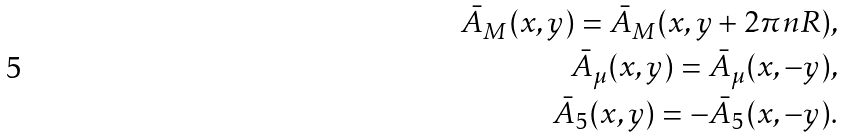Convert formula to latex. <formula><loc_0><loc_0><loc_500><loc_500>\bar { A } _ { M } ( x , y ) = \bar { A } _ { M } ( x , y + 2 \pi n R ) , \\ \bar { A } _ { \mu } ( x , y ) = \bar { A } _ { \mu } ( x , - y ) , \\ \bar { A } _ { 5 } ( x , y ) = - \bar { A } _ { 5 } ( x , - y ) .</formula> 